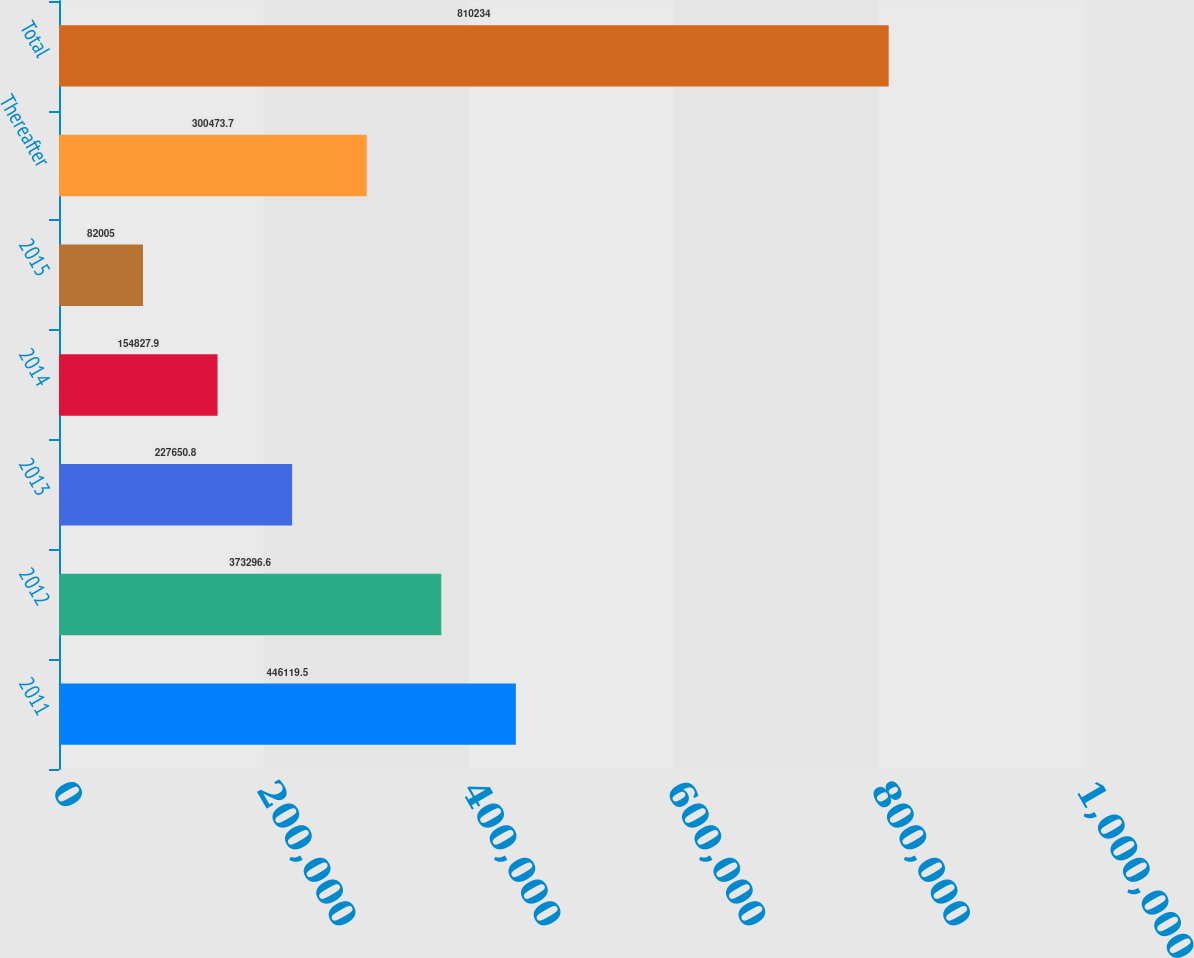<chart> <loc_0><loc_0><loc_500><loc_500><bar_chart><fcel>2011<fcel>2012<fcel>2013<fcel>2014<fcel>2015<fcel>Thereafter<fcel>Total<nl><fcel>446120<fcel>373297<fcel>227651<fcel>154828<fcel>82005<fcel>300474<fcel>810234<nl></chart> 